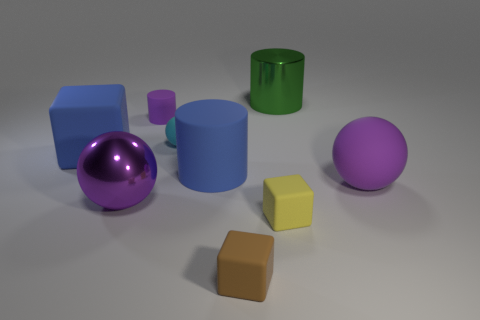Is there a big metallic sphere in front of the ball right of the green metal thing on the right side of the cyan rubber thing?
Offer a very short reply. Yes. There is a large matte thing on the right side of the large green cylinder; is its shape the same as the large purple thing that is to the left of the small yellow matte cube?
Provide a succinct answer. Yes. Are there more big blue rubber cylinders that are on the left side of the green shiny thing than tiny green balls?
Your answer should be very brief. Yes. What number of objects are purple matte spheres or rubber blocks?
Your answer should be compact. 4. What is the color of the big rubber block?
Make the answer very short. Blue. What number of other objects are there of the same color as the small rubber cylinder?
Keep it short and to the point. 2. There is a small purple cylinder; are there any metallic things behind it?
Your response must be concise. Yes. What color is the large metal thing in front of the purple ball to the right of the large metal ball that is right of the large rubber block?
Keep it short and to the point. Purple. What number of objects are both in front of the big green shiny cylinder and on the right side of the large blue matte cube?
Offer a terse response. 7. How many cubes are either large blue matte things or cyan rubber things?
Ensure brevity in your answer.  1. 